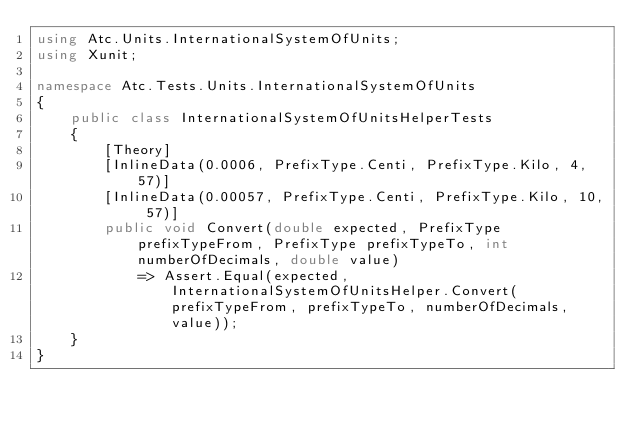Convert code to text. <code><loc_0><loc_0><loc_500><loc_500><_C#_>using Atc.Units.InternationalSystemOfUnits;
using Xunit;

namespace Atc.Tests.Units.InternationalSystemOfUnits
{
    public class InternationalSystemOfUnitsHelperTests
    {
        [Theory]
        [InlineData(0.0006, PrefixType.Centi, PrefixType.Kilo, 4, 57)]
        [InlineData(0.00057, PrefixType.Centi, PrefixType.Kilo, 10, 57)]
        public void Convert(double expected, PrefixType prefixTypeFrom, PrefixType prefixTypeTo, int numberOfDecimals, double value)
            => Assert.Equal(expected, InternationalSystemOfUnitsHelper.Convert(prefixTypeFrom, prefixTypeTo, numberOfDecimals, value));
    }
}</code> 